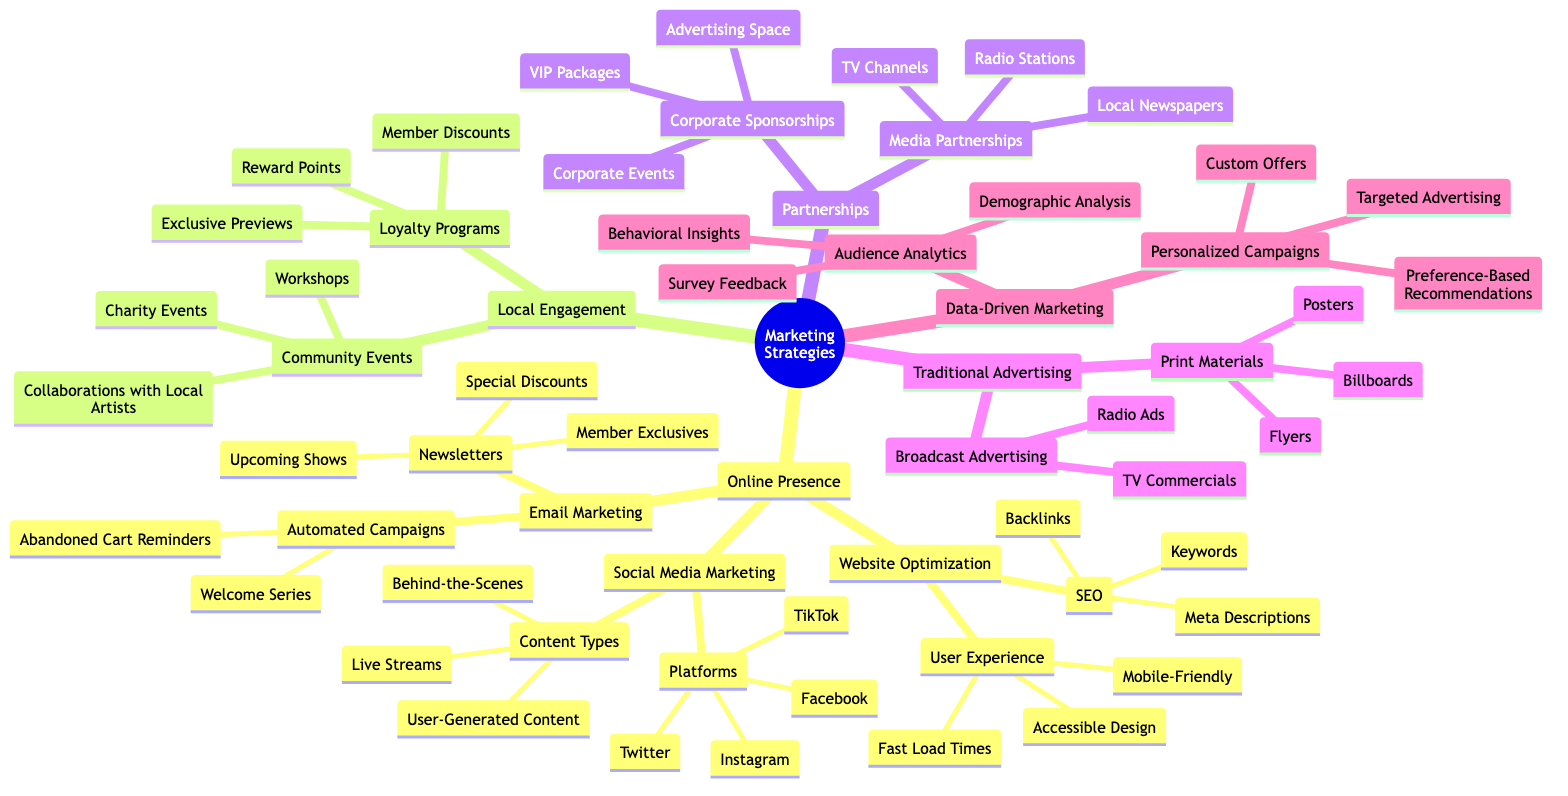What are the three main categories of marketing strategies shown? The diagram starts with the central theme "Marketing Strategies for Modern Theaters," which branches into three main categories: "Online Presence," "Local Engagement," and "Partnerships." These are the first-level nodes directly connected to the root.
Answer: Online Presence, Local Engagement, Partnerships How many content types are there under Social Media Marketing? Under the "Social Media Marketing" node, the sub-node "Content Types" lists three items: "Behind-the-Scenes," "Live Streams," and "User-Generated Content." By counting these listed items, the total comes to three.
Answer: 3 What are two elements of Website Optimization related to User Experience? Looking at the "Website Optimization" branch, under "User Experience," there are three listed elements: "Mobile-Friendly," "Fast Load Times," and "Accessible Design." Any two of these could be correct, but I will mention two here.
Answer: Mobile-Friendly, Fast Load Times Which local engagement strategy involves the community? The "Community Events" node under "Local Engagement" specifically addresses strategies that involve the community, including "Collaborations with Local Artists," "Workshops," and "Charity Events."
Answer: Community Events What type of partnership includes VIP Packages? The "Corporate Sponsorships" node under "Partnerships" mentions "VIP Packages" as one of the strategies. This suggests that VIP Packages are part of the corporate sponsorship approach.
Answer: Corporate Sponsorships How many types of advertising are listed under Traditional Advertising? The "Traditional Advertising" category has two main subcategories: "Print Materials" and "Broadcast Advertising." Counting these gives a total of two types of advertising.
Answer: 2 What are two components of Data-Driven Marketing? The category "Data-Driven Marketing" splits into two branches: "Audience Analytics" and "Personalized Campaigns." Each of these branches contains further specific strategies, but just naming two components, one from each branch would suffice.
Answer: Audience Analytics, Personalized Campaigns Which social media platform is NOT listed in the diagram? The diagram provides a list of platforms including "Facebook," "Instagram," "Twitter," and "TikTok." Any other popular social media platform that is not in that list could be a valid answer.
Answer: [Any platform not listed, e.g., Snapchat] 